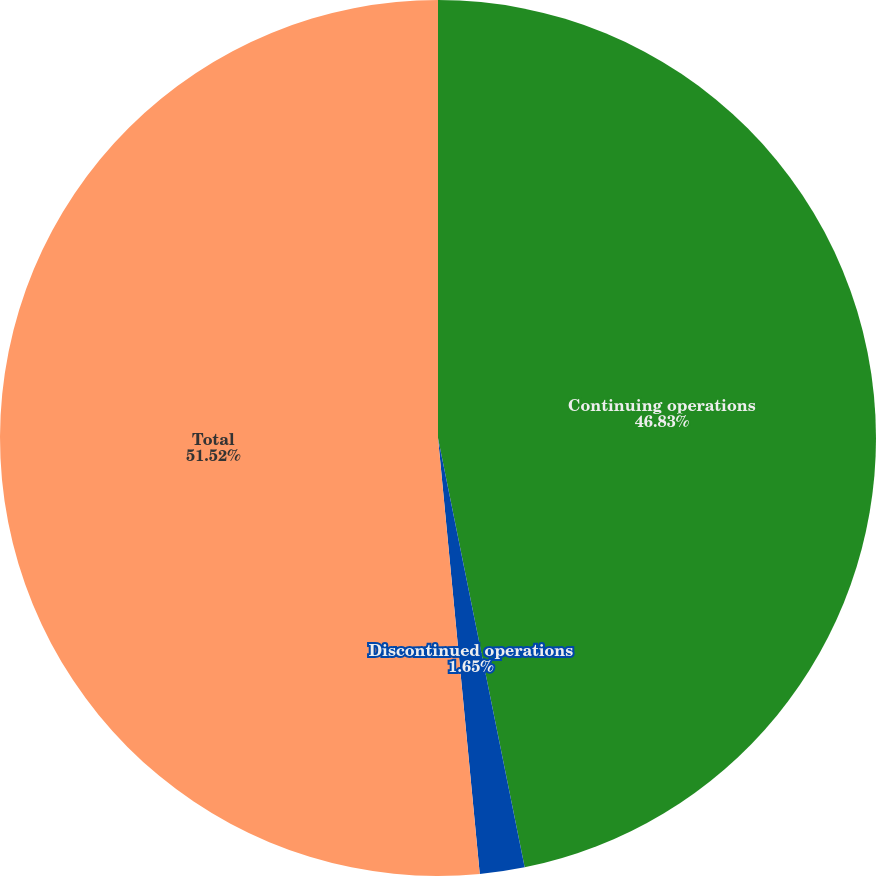Convert chart. <chart><loc_0><loc_0><loc_500><loc_500><pie_chart><fcel>Continuing operations<fcel>Discontinued operations<fcel>Total<nl><fcel>46.83%<fcel>1.65%<fcel>51.52%<nl></chart> 